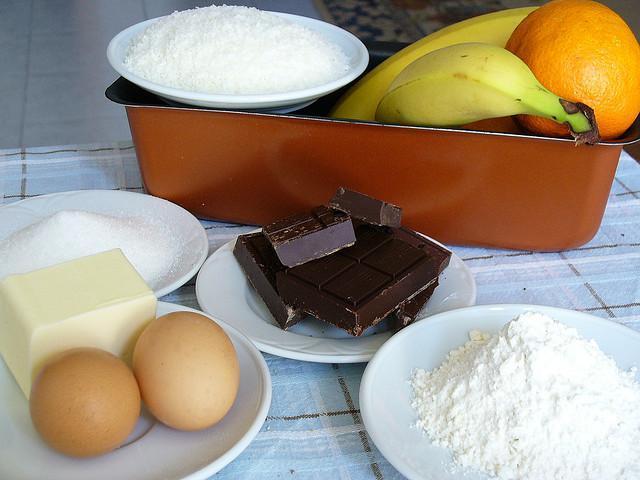How many pieces of chocolate are on the plate?
Give a very brief answer. 5. How many dishes are there?
Give a very brief answer. 5. How many zebras are facing left?
Give a very brief answer. 0. 